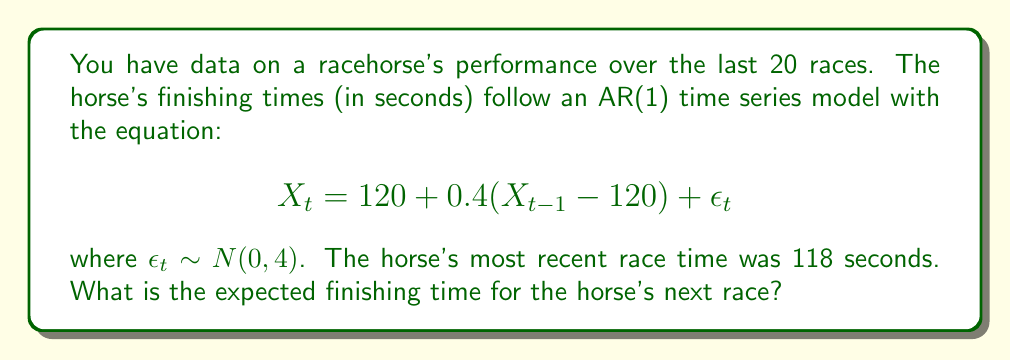Teach me how to tackle this problem. To solve this problem, we need to understand the AR(1) model and use it to make a prediction. Let's break it down step-by-step:

1) The AR(1) model is given by:
   $$X_t = 120 + 0.4(X_{t-1} - 120) + \epsilon_t$$

2) In this equation:
   - 120 is the mean level of the series
   - 0.4 is the autoregressive coefficient
   - $X_{t-1}$ is the previous observation
   - $\epsilon_t$ is the error term, which follows a normal distribution with mean 0 and variance 4

3) To predict the next value, we use the equation without the error term (as we can't predict random error):
   $$E[X_t] = 120 + 0.4(X_{t-1} - 120)$$

4) We're told that the most recent race time ($X_{t-1}$) was 118 seconds. Let's substitute this into our equation:
   $$E[X_t] = 120 + 0.4(118 - 120)$$

5) Now let's solve:
   $$E[X_t] = 120 + 0.4(-2)$$
   $$E[X_t] = 120 - 0.8$$
   $$E[X_t] = 119.2$$

Therefore, the expected finishing time for the horse's next race is 119.2 seconds.
Answer: 119.2 seconds 